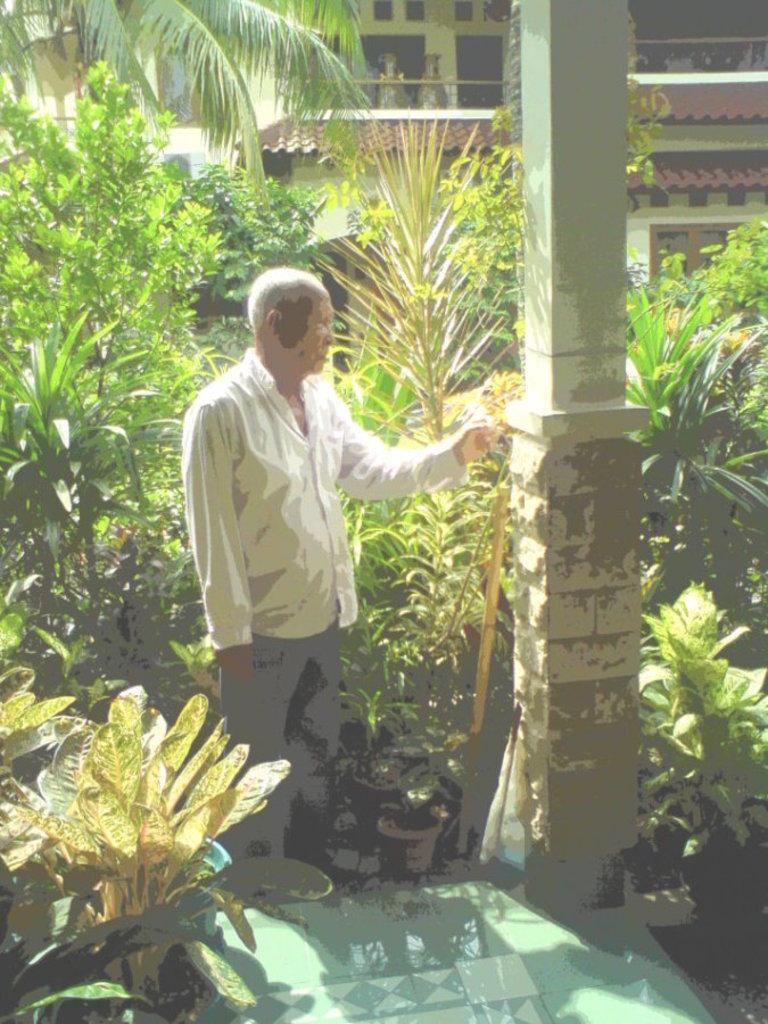What is the person in the image doing? The person is standing near a pillar. What can be seen in the background of the image? There are plants and a house in the background of the image. What level of excitement can be observed in the person near the pillar? The image does not provide information about the person's level of excitement, so it cannot be determined from the image. 